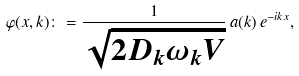<formula> <loc_0><loc_0><loc_500><loc_500>\varphi ( x , k ) \colon = \frac { 1 } { \sqrt { 2 D _ { k } \omega _ { k } V } } \, a ( k ) \, e ^ { - i k x } ,</formula> 